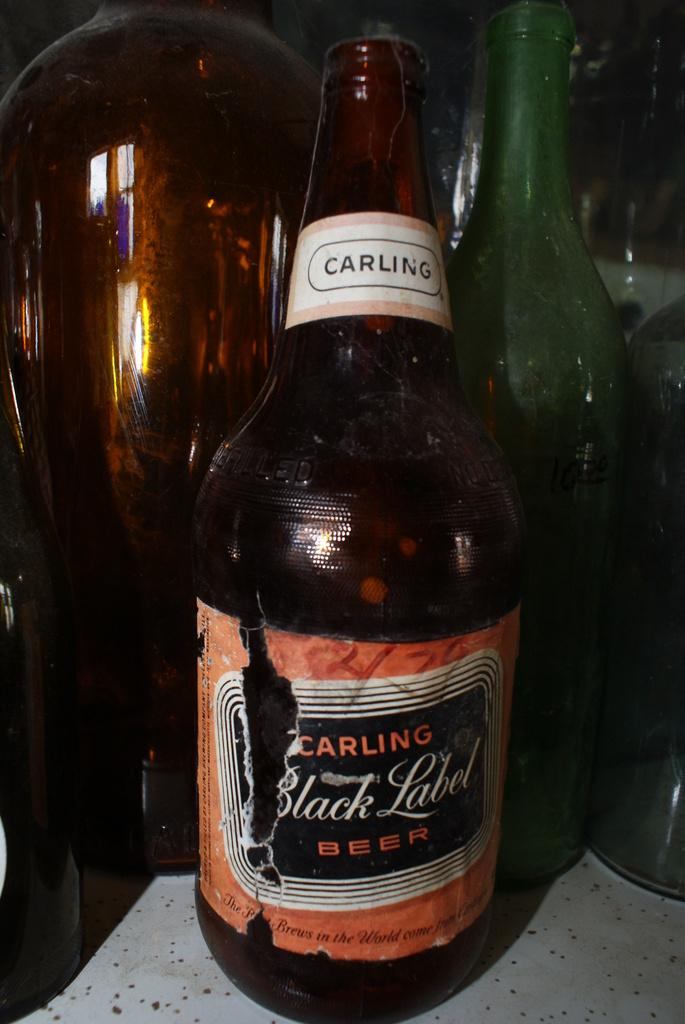What objects are present in the image? There are bottles in the image. Can you hear a whistle in the image? There is no mention of a whistle in the image, so it cannot be heard. What type of curve can be seen in the image? There is no curve mentioned or visible in the image. 